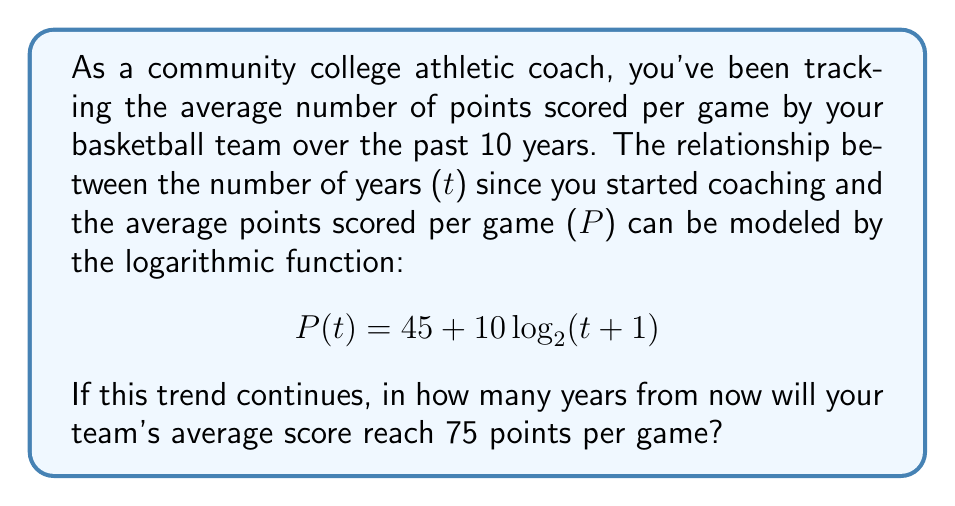Can you solve this math problem? Let's approach this step-by-step:

1) We want to find t when P(t) = 75. So, we need to solve the equation:
   
   $75 = 45 + 10\log_2(t+1)$

2) Subtract 45 from both sides:
   
   $30 = 10\log_2(t+1)$

3) Divide both sides by 10:
   
   $3 = \log_2(t+1)$

4) To solve for t, we need to apply the inverse function (exponential) to both sides:
   
   $2^3 = t+1$

5) Simplify the left side:
   
   $8 = t+1$

6) Subtract 1 from both sides to isolate t:
   
   $7 = t$

Therefore, if the trend continues, the team's average score will reach 75 points per game in 7 years from now.
Answer: 7 years 